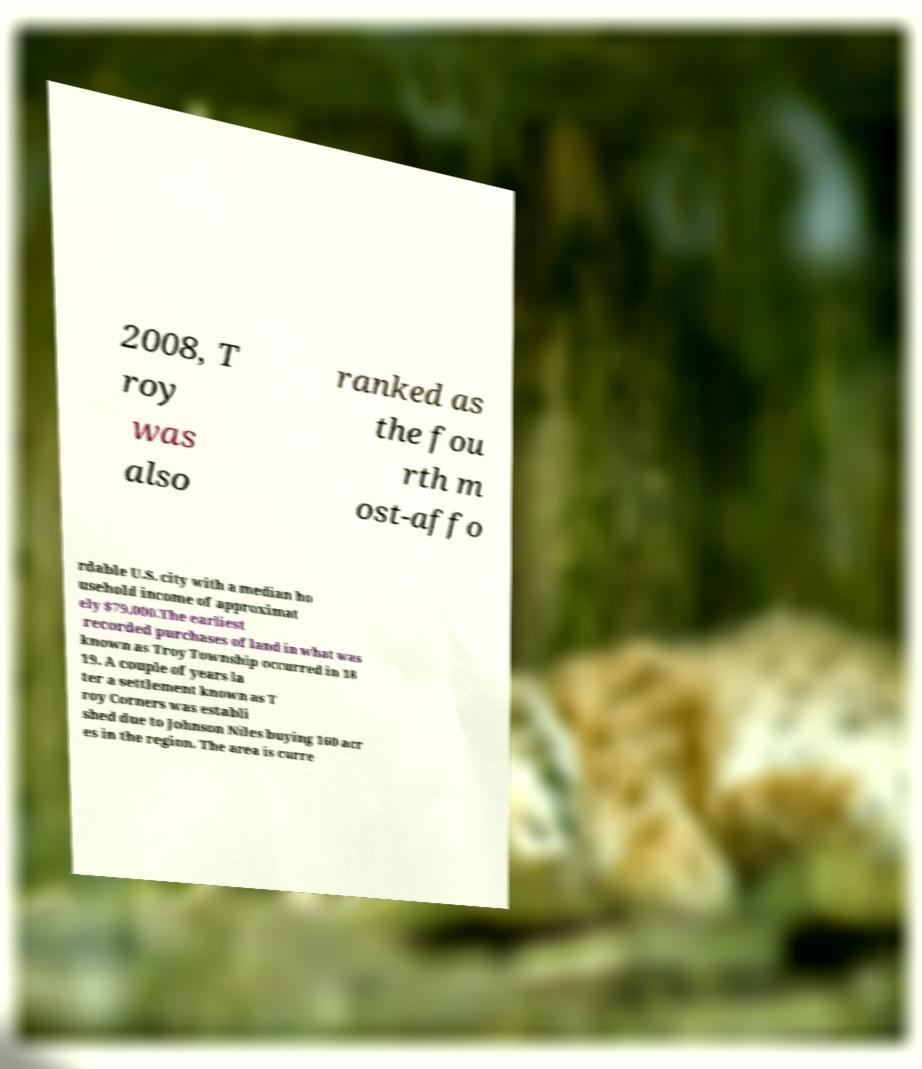Please identify and transcribe the text found in this image. 2008, T roy was also ranked as the fou rth m ost-affo rdable U.S. city with a median ho usehold income of approximat ely $79,000.The earliest recorded purchases of land in what was known as Troy Township occurred in 18 19. A couple of years la ter a settlement known as T roy Corners was establi shed due to Johnson Niles buying 160 acr es in the region. The area is curre 